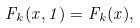Convert formula to latex. <formula><loc_0><loc_0><loc_500><loc_500>F _ { k } ( x , 1 ) = F _ { k } ( x ) ,</formula> 